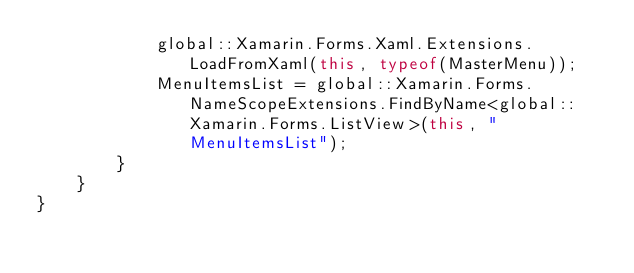Convert code to text. <code><loc_0><loc_0><loc_500><loc_500><_C#_>            global::Xamarin.Forms.Xaml.Extensions.LoadFromXaml(this, typeof(MasterMenu));
            MenuItemsList = global::Xamarin.Forms.NameScopeExtensions.FindByName<global::Xamarin.Forms.ListView>(this, "MenuItemsList");
        }
    }
}
</code> 